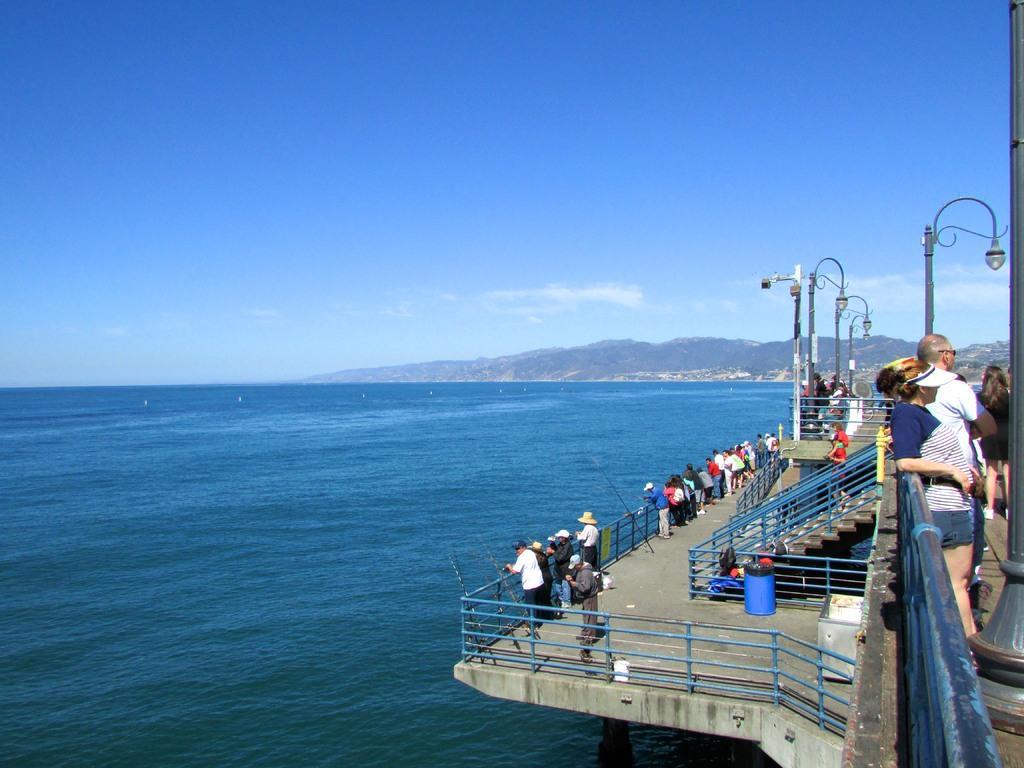In one or two sentences, can you explain what this image depicts? In this image we can see many people. There are few street lights in the image. We can see the sea in the image. There are few clouds in the sky. There are few objects on the ground. There are few hills in the image. 